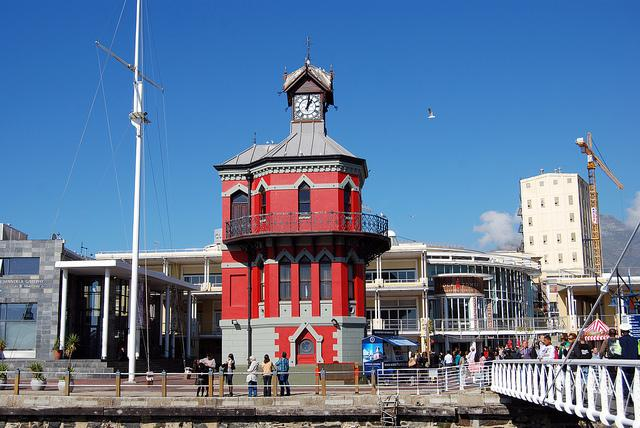What color are the rectangular bricks on the very bottom of the tower? Please explain your reasoning. gray. A tower is made of red and gray bricks with the gray being wider than they are tall. 